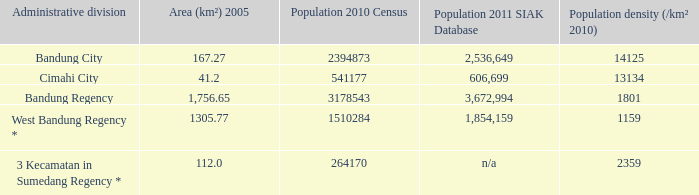What is the area of cimahi city? 41.2. 